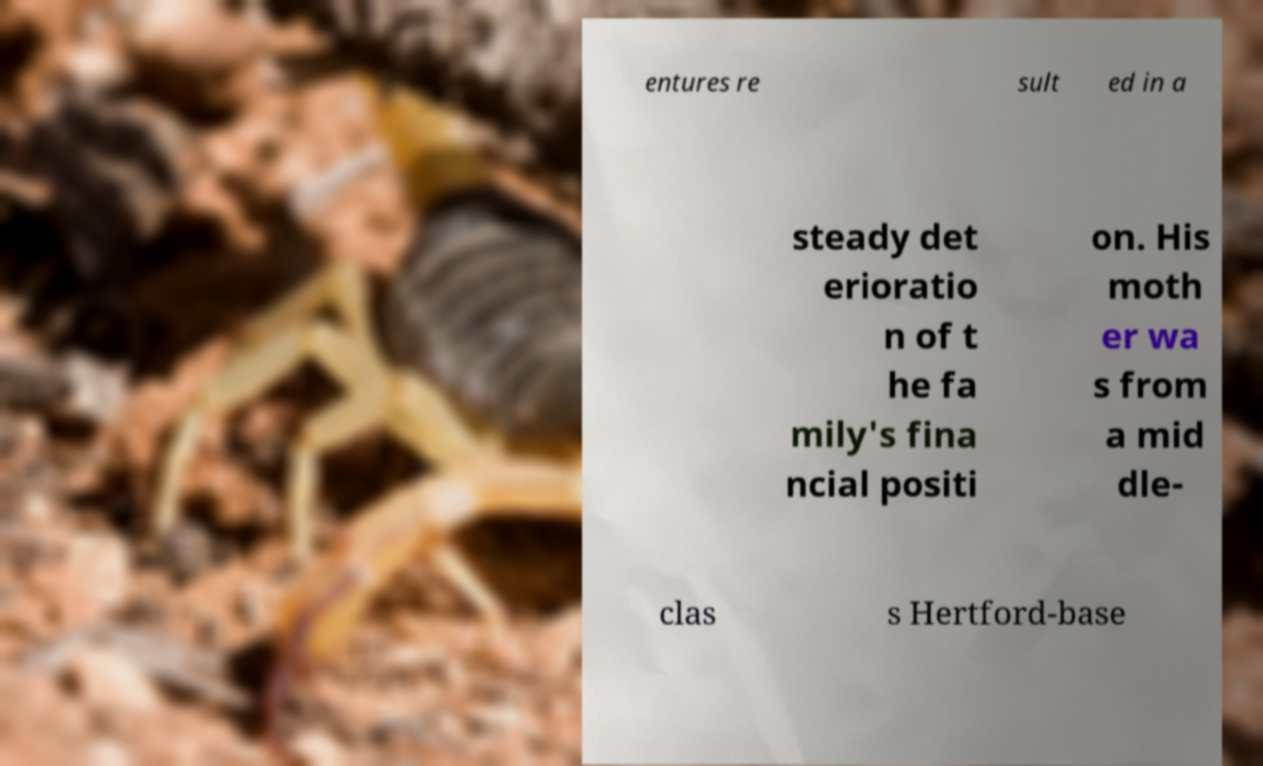What messages or text are displayed in this image? I need them in a readable, typed format. entures re sult ed in a steady det erioratio n of t he fa mily's fina ncial positi on. His moth er wa s from a mid dle- clas s Hertford-base 